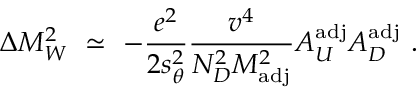<formula> <loc_0><loc_0><loc_500><loc_500>\Delta M _ { W } ^ { 2 } \ \simeq \ - { \frac { e ^ { 2 } } { 2 s _ { \theta } ^ { 2 } } } { \frac { v ^ { 4 } } { N _ { D } ^ { 2 } M _ { a d j } ^ { 2 } } } A _ { U } ^ { a d j } A _ { D } ^ { a d j } \ .</formula> 